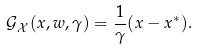<formula> <loc_0><loc_0><loc_500><loc_500>\mathcal { G } _ { \mathcal { X } } ( x , w , \gamma ) = \frac { 1 } { \gamma } ( x - x ^ { * } ) .</formula> 